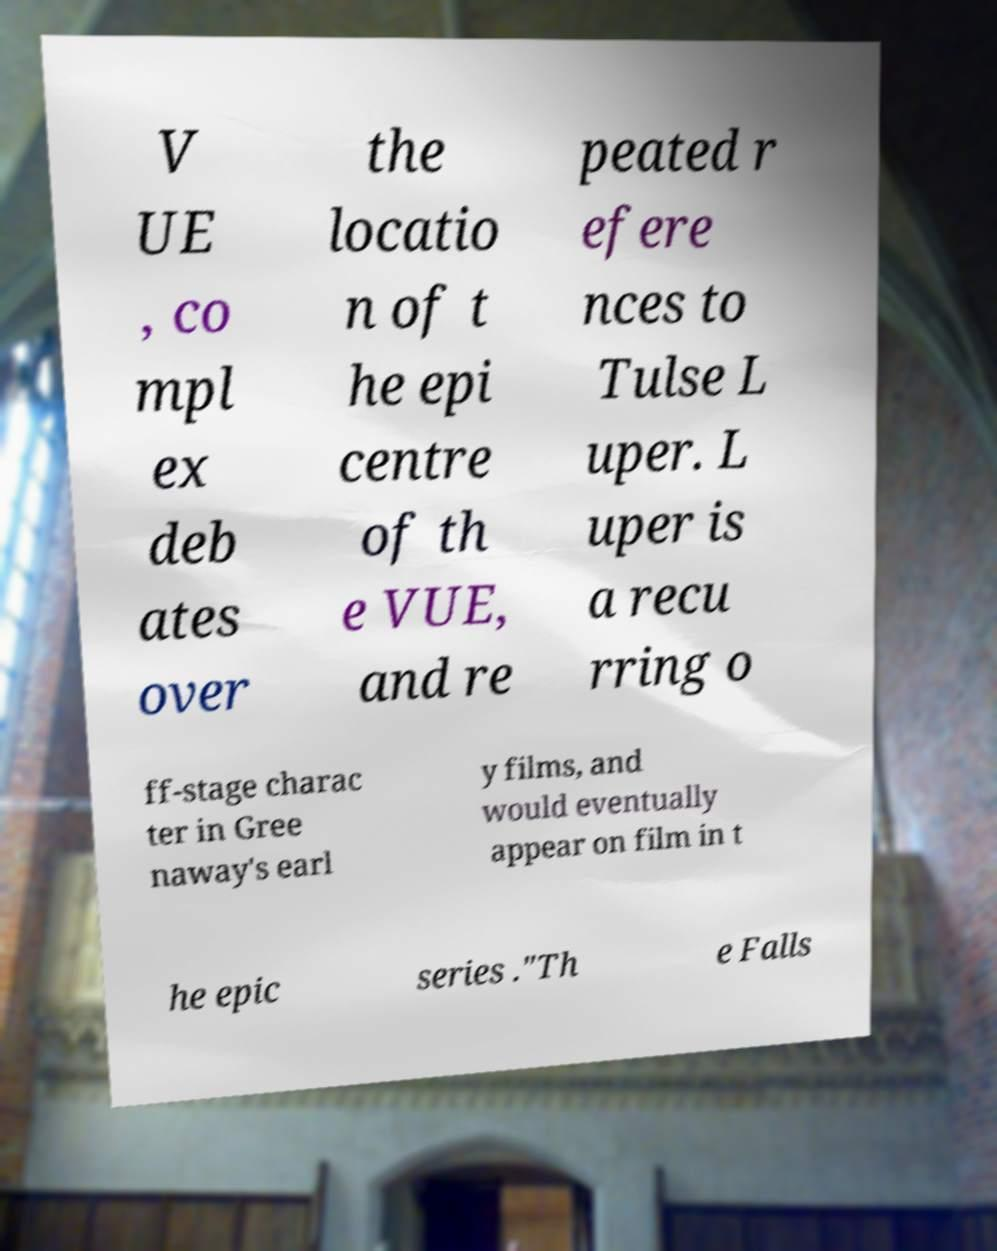Can you accurately transcribe the text from the provided image for me? V UE , co mpl ex deb ates over the locatio n of t he epi centre of th e VUE, and re peated r efere nces to Tulse L uper. L uper is a recu rring o ff-stage charac ter in Gree naway's earl y films, and would eventually appear on film in t he epic series ."Th e Falls 